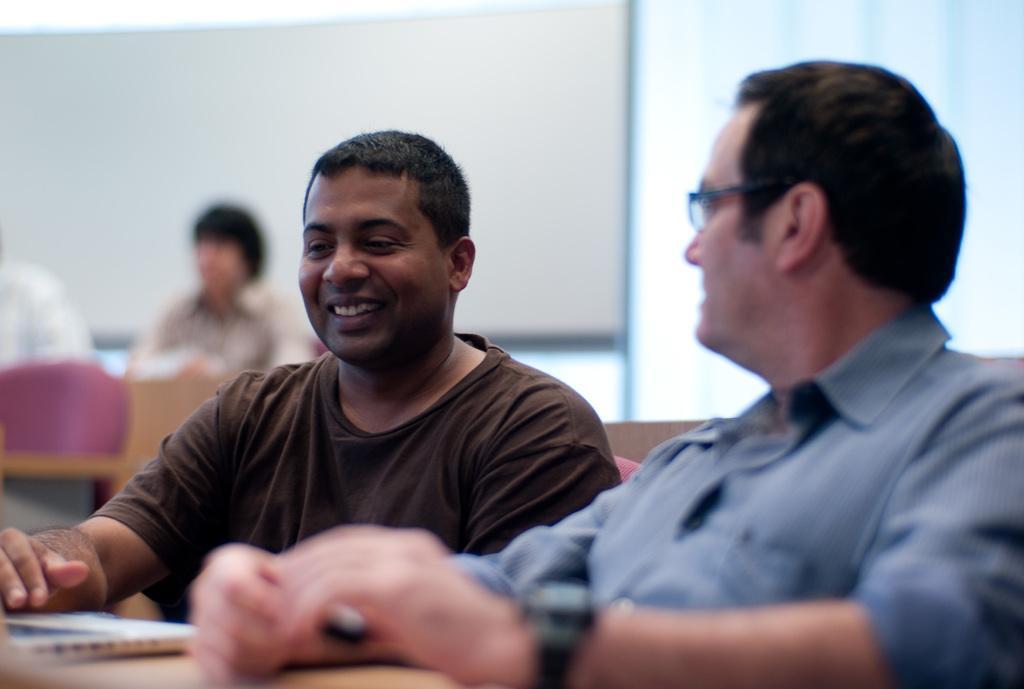Please provide a concise description of this image. In the background we can see a white board, a person and a chair. On the right side we can see a man wore spectacles and a wrist watch. Beside to him we can see an another man wearing brown t-shirt and smiling. Near to them we can see a book. 